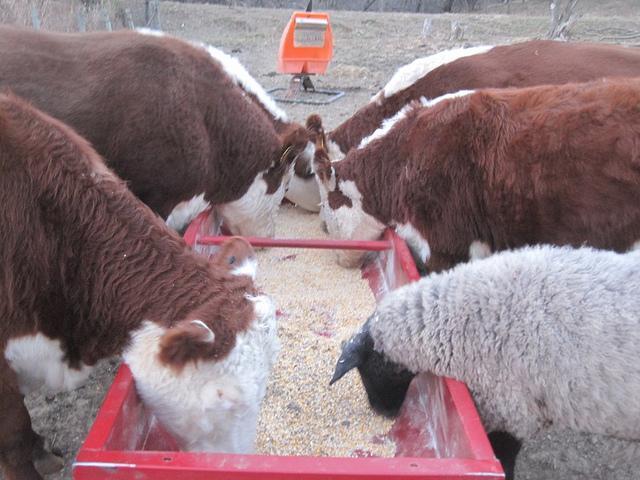How many different species in this picture?
Give a very brief answer. 2. How many cows are in the picture?
Give a very brief answer. 5. How many laptops are there?
Give a very brief answer. 0. 